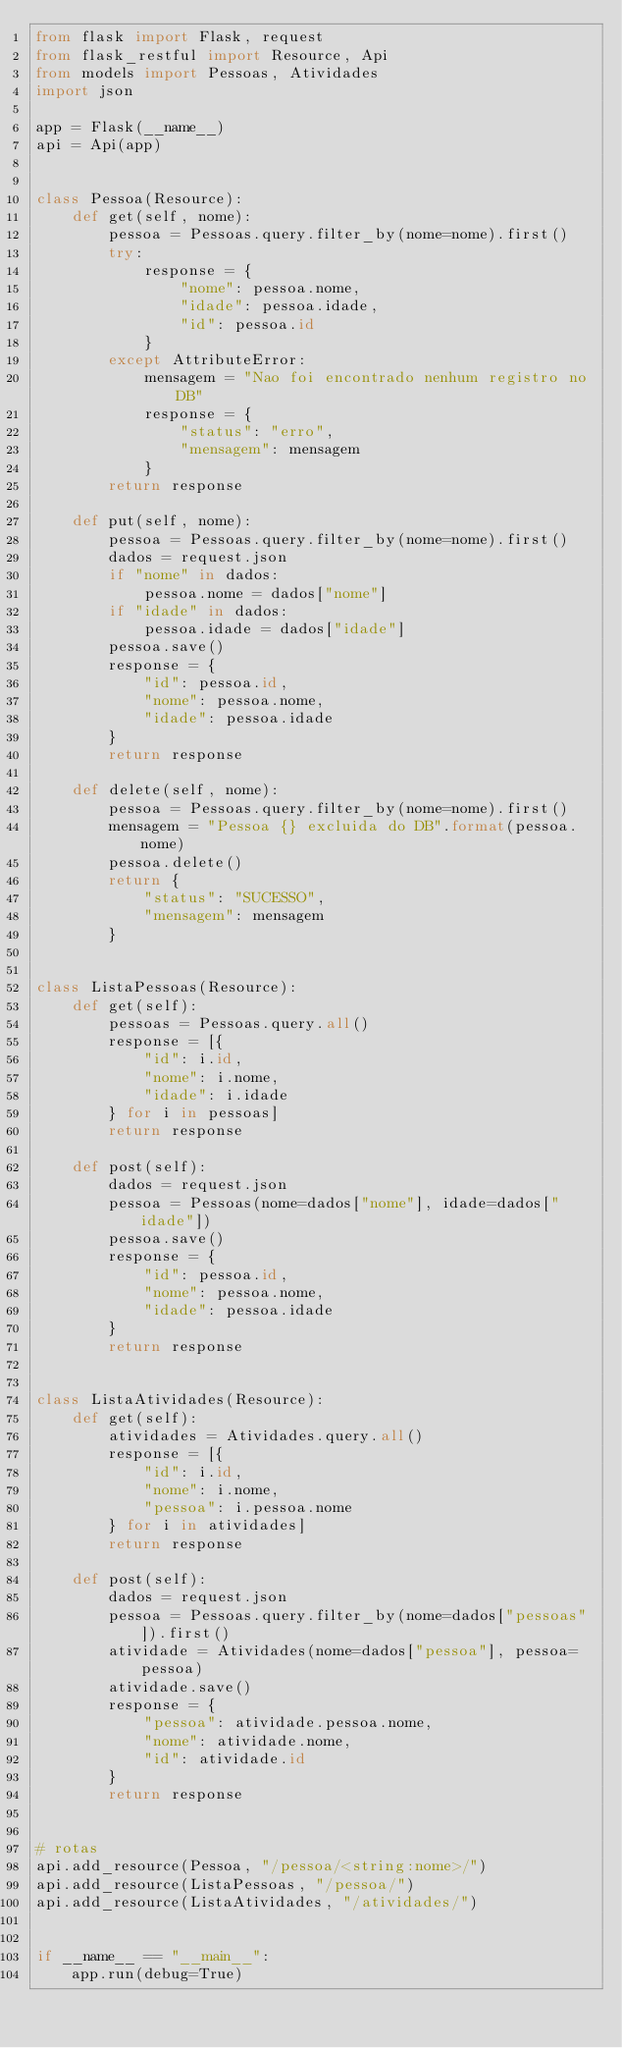Convert code to text. <code><loc_0><loc_0><loc_500><loc_500><_Python_>from flask import Flask, request
from flask_restful import Resource, Api
from models import Pessoas, Atividades
import json

app = Flask(__name__)
api = Api(app)


class Pessoa(Resource):
    def get(self, nome):
        pessoa = Pessoas.query.filter_by(nome=nome).first()
        try:
            response = {
                "nome": pessoa.nome,
                "idade": pessoa.idade,
                "id": pessoa.id
            }
        except AttributeError:
            mensagem = "Nao foi encontrado nenhum registro no DB"
            response = {
                "status": "erro",
                "mensagem": mensagem
            }
        return response

    def put(self, nome):
        pessoa = Pessoas.query.filter_by(nome=nome).first()
        dados = request.json
        if "nome" in dados:
            pessoa.nome = dados["nome"]
        if "idade" in dados:
            pessoa.idade = dados["idade"]
        pessoa.save()
        response = {
            "id": pessoa.id,
            "nome": pessoa.nome,
            "idade": pessoa.idade
        }
        return response

    def delete(self, nome):
        pessoa = Pessoas.query.filter_by(nome=nome).first()
        mensagem = "Pessoa {} excluida do DB".format(pessoa.nome)
        pessoa.delete()
        return {
            "status": "SUCESSO",
            "mensagem": mensagem
        }


class ListaPessoas(Resource):
    def get(self):
        pessoas = Pessoas.query.all()
        response = [{
            "id": i.id,
            "nome": i.nome,
            "idade": i.idade
        } for i in pessoas]
        return response

    def post(self):
        dados = request.json
        pessoa = Pessoas(nome=dados["nome"], idade=dados["idade"])
        pessoa.save()
        response = {
            "id": pessoa.id,
            "nome": pessoa.nome,
            "idade": pessoa.idade
        }
        return response


class ListaAtividades(Resource):
    def get(self):
        atividades = Atividades.query.all()
        response = [{
            "id": i.id,
            "nome": i.nome,
            "pessoa": i.pessoa.nome
        } for i in atividades]
        return response

    def post(self):
        dados = request.json
        pessoa = Pessoas.query.filter_by(nome=dados["pessoas"]).first()
        atividade = Atividades(nome=dados["pessoa"], pessoa=pessoa)
        atividade.save()
        response = {
            "pessoa": atividade.pessoa.nome,
            "nome": atividade.nome,
            "id": atividade.id
        }
        return response


# rotas
api.add_resource(Pessoa, "/pessoa/<string:nome>/")
api.add_resource(ListaPessoas, "/pessoa/")
api.add_resource(ListaAtividades, "/atividades/")


if __name__ == "__main__":
    app.run(debug=True)
</code> 